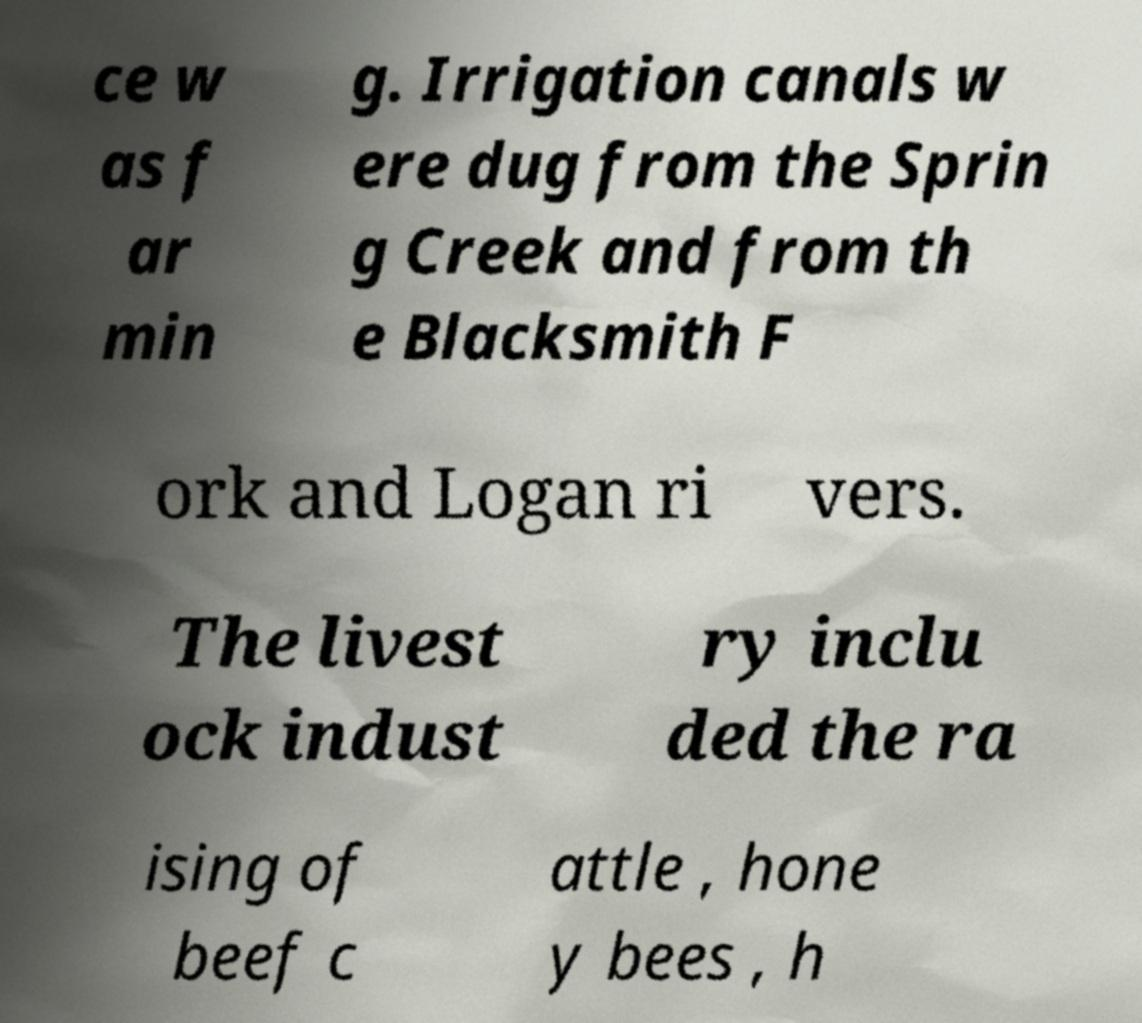Can you read and provide the text displayed in the image?This photo seems to have some interesting text. Can you extract and type it out for me? ce w as f ar min g. Irrigation canals w ere dug from the Sprin g Creek and from th e Blacksmith F ork and Logan ri vers. The livest ock indust ry inclu ded the ra ising of beef c attle , hone y bees , h 